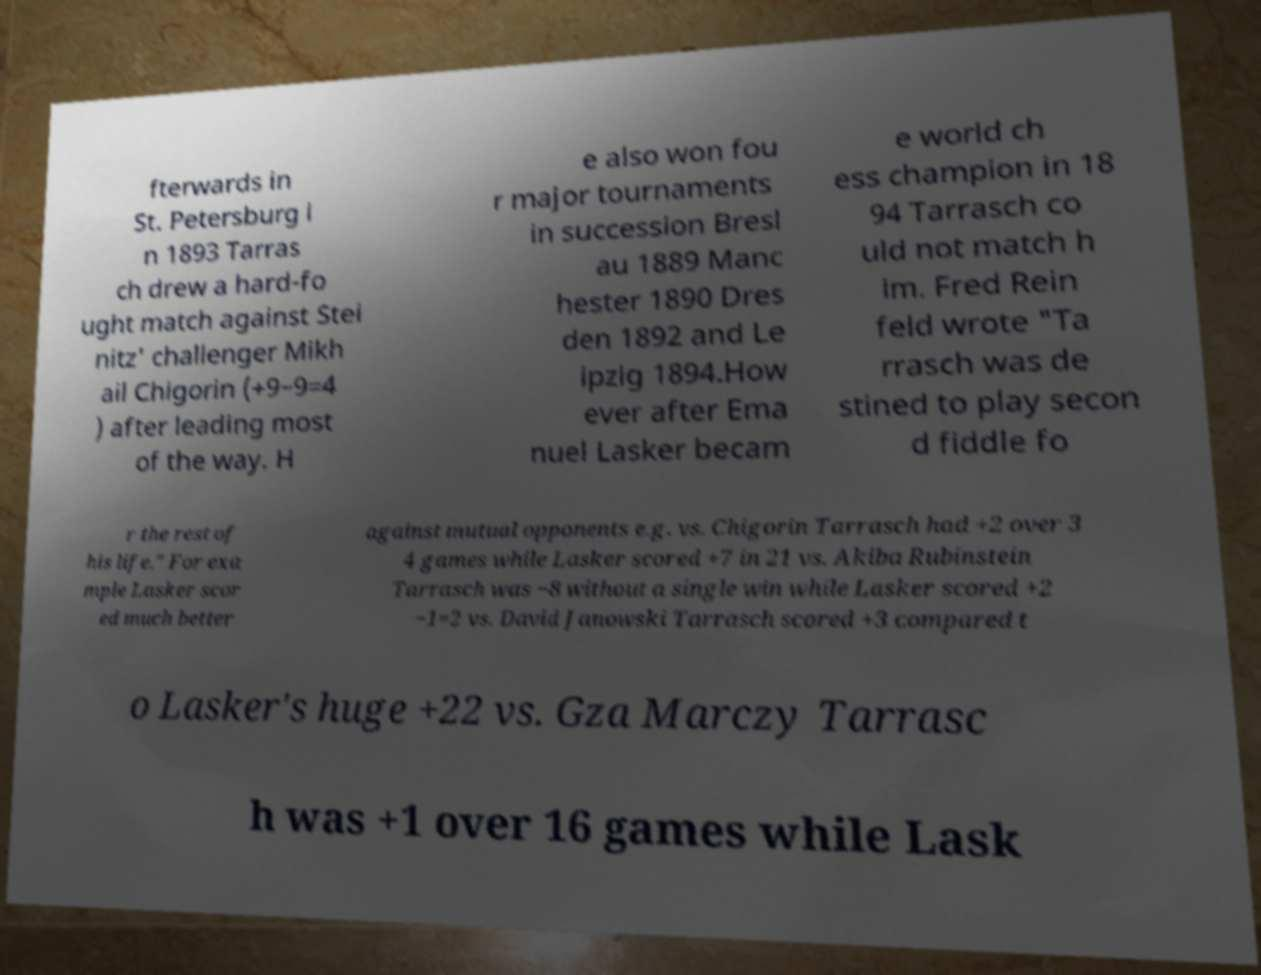Please identify and transcribe the text found in this image. fterwards in St. Petersburg i n 1893 Tarras ch drew a hard-fo ught match against Stei nitz' challenger Mikh ail Chigorin (+9−9=4 ) after leading most of the way. H e also won fou r major tournaments in succession Bresl au 1889 Manc hester 1890 Dres den 1892 and Le ipzig 1894.How ever after Ema nuel Lasker becam e world ch ess champion in 18 94 Tarrasch co uld not match h im. Fred Rein feld wrote "Ta rrasch was de stined to play secon d fiddle fo r the rest of his life." For exa mple Lasker scor ed much better against mutual opponents e.g. vs. Chigorin Tarrasch had +2 over 3 4 games while Lasker scored +7 in 21 vs. Akiba Rubinstein Tarrasch was −8 without a single win while Lasker scored +2 −1=2 vs. David Janowski Tarrasch scored +3 compared t o Lasker's huge +22 vs. Gza Marczy Tarrasc h was +1 over 16 games while Lask 